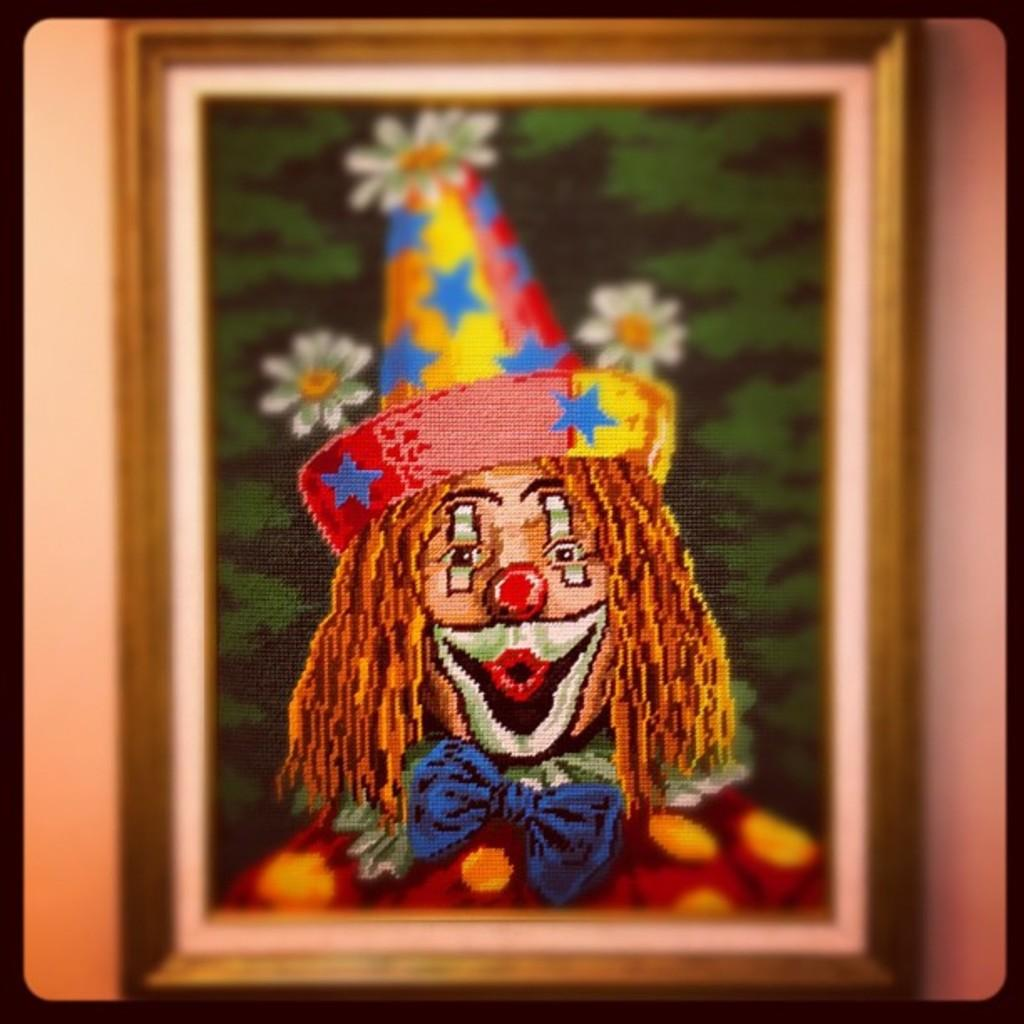What object is present in the image that holds a picture? There is a photo frame in the image that holds a picture. What is depicted in the photo frame? The photo frame contains a picture of a person and flowers. What is the background of the photo frame? The background of the photo frame is a plane. What is the tendency of the dog in the image? There is no dog present in the image. How is the sister related to the person in the photo frame? There is no mention of a sister in the image or the provided facts. 